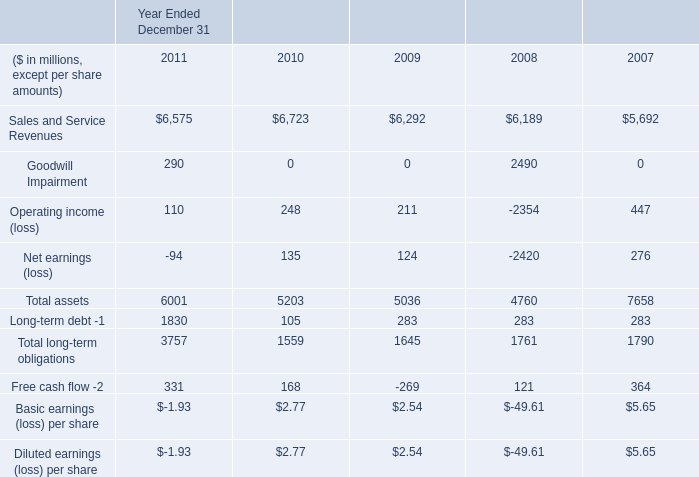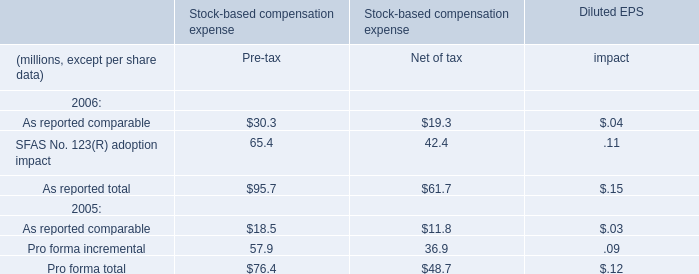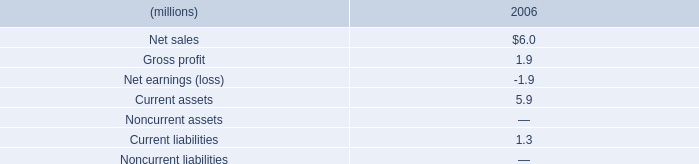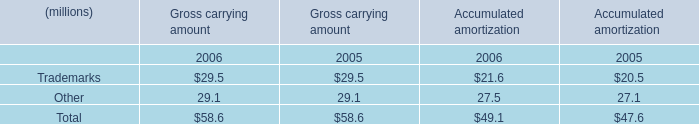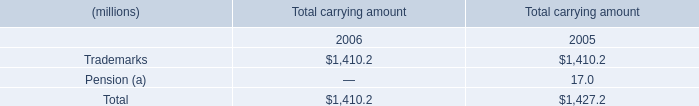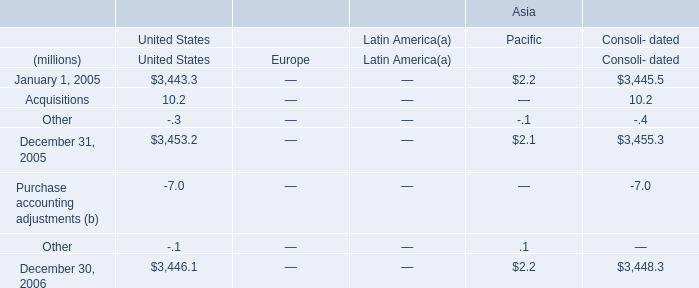What is the sum of the Other in the years where Trademarks greater than 50? (in million) 
Computations: (29.1 + 27.5)
Answer: 56.6. 